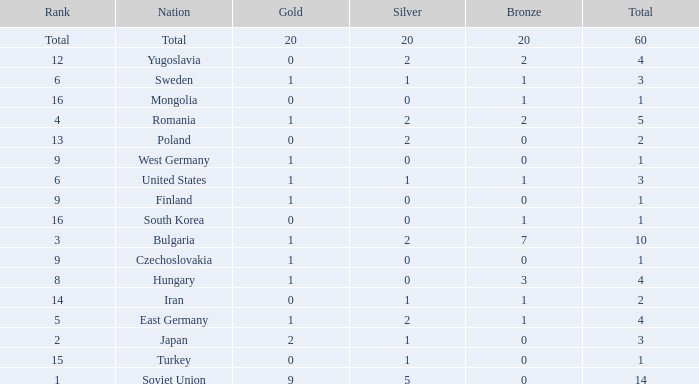What is the sum of golds for ranks of 6 and totals over 3? None. 